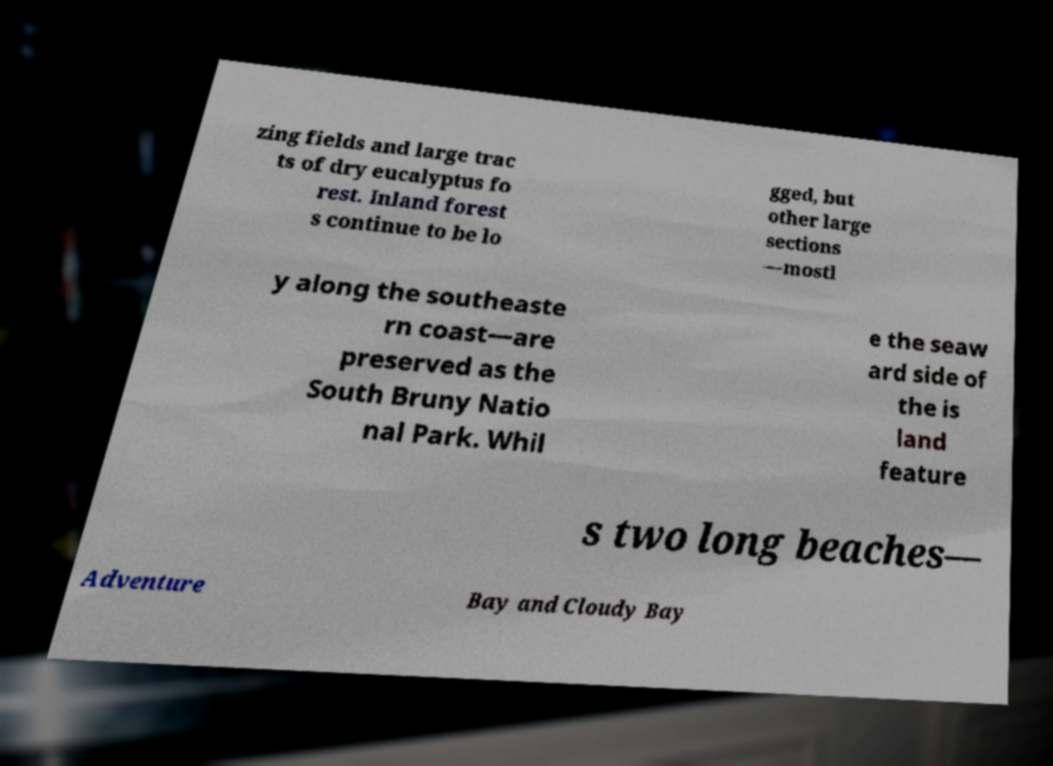Can you accurately transcribe the text from the provided image for me? zing fields and large trac ts of dry eucalyptus fo rest. Inland forest s continue to be lo gged, but other large sections —mostl y along the southeaste rn coast—are preserved as the South Bruny Natio nal Park. Whil e the seaw ard side of the is land feature s two long beaches— Adventure Bay and Cloudy Bay 